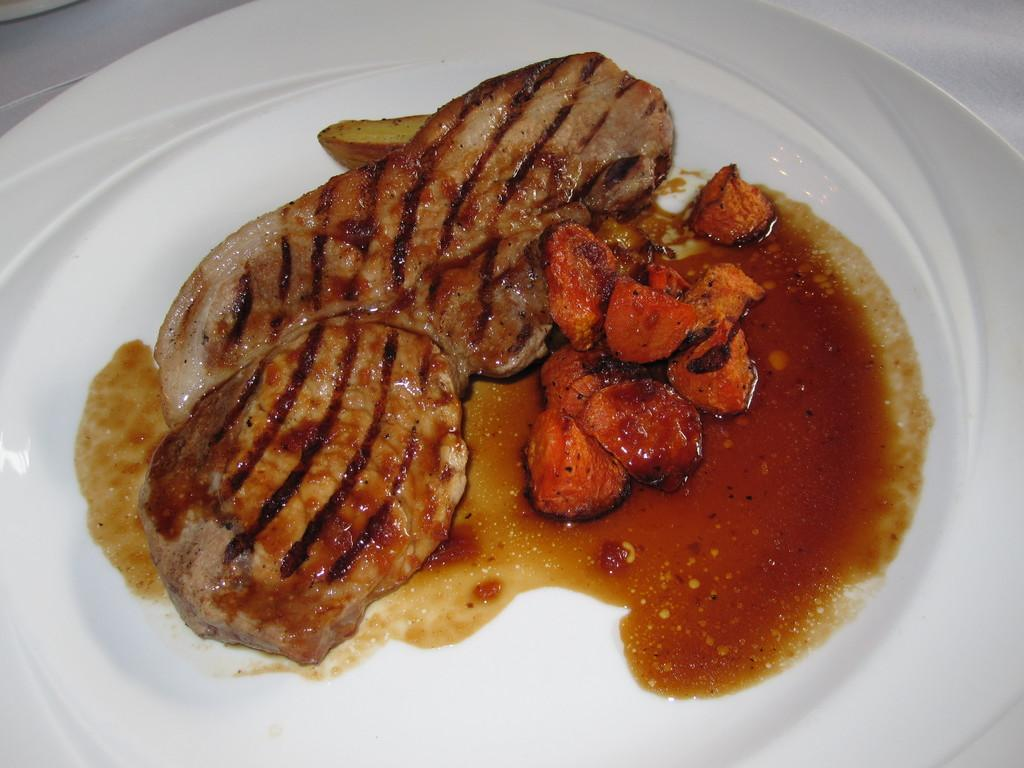What is present on the plate in the image? There are food items on a plate in the image. What type of journey does the smoke take in the image? There is no smoke present in the image, so it is not possible to answer that question. 